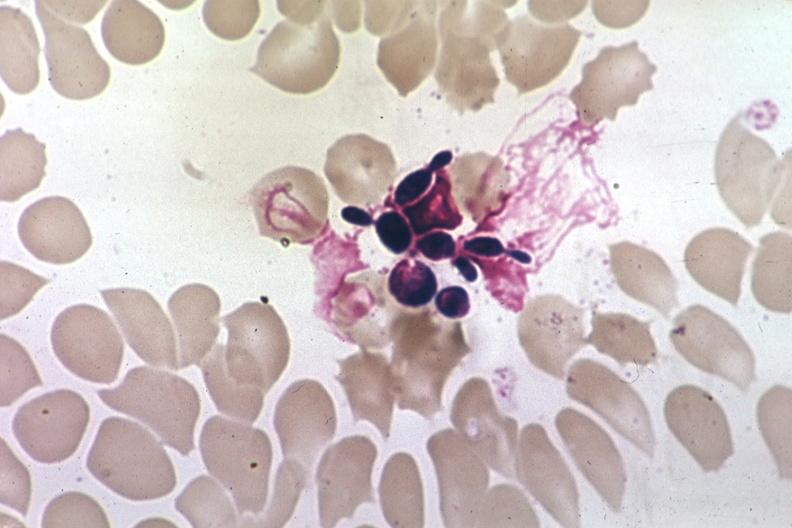s granuloma present?
Answer the question using a single word or phrase. No 